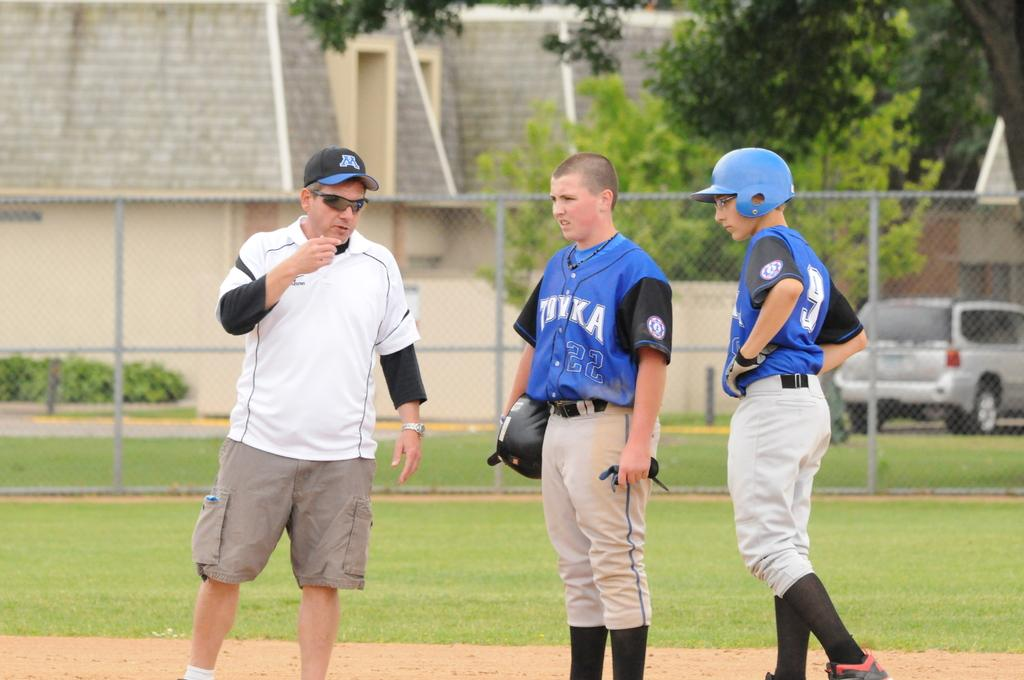<image>
Provide a brief description of the given image. Baseball player wearing a jersey that says Tonka standing on the field. 